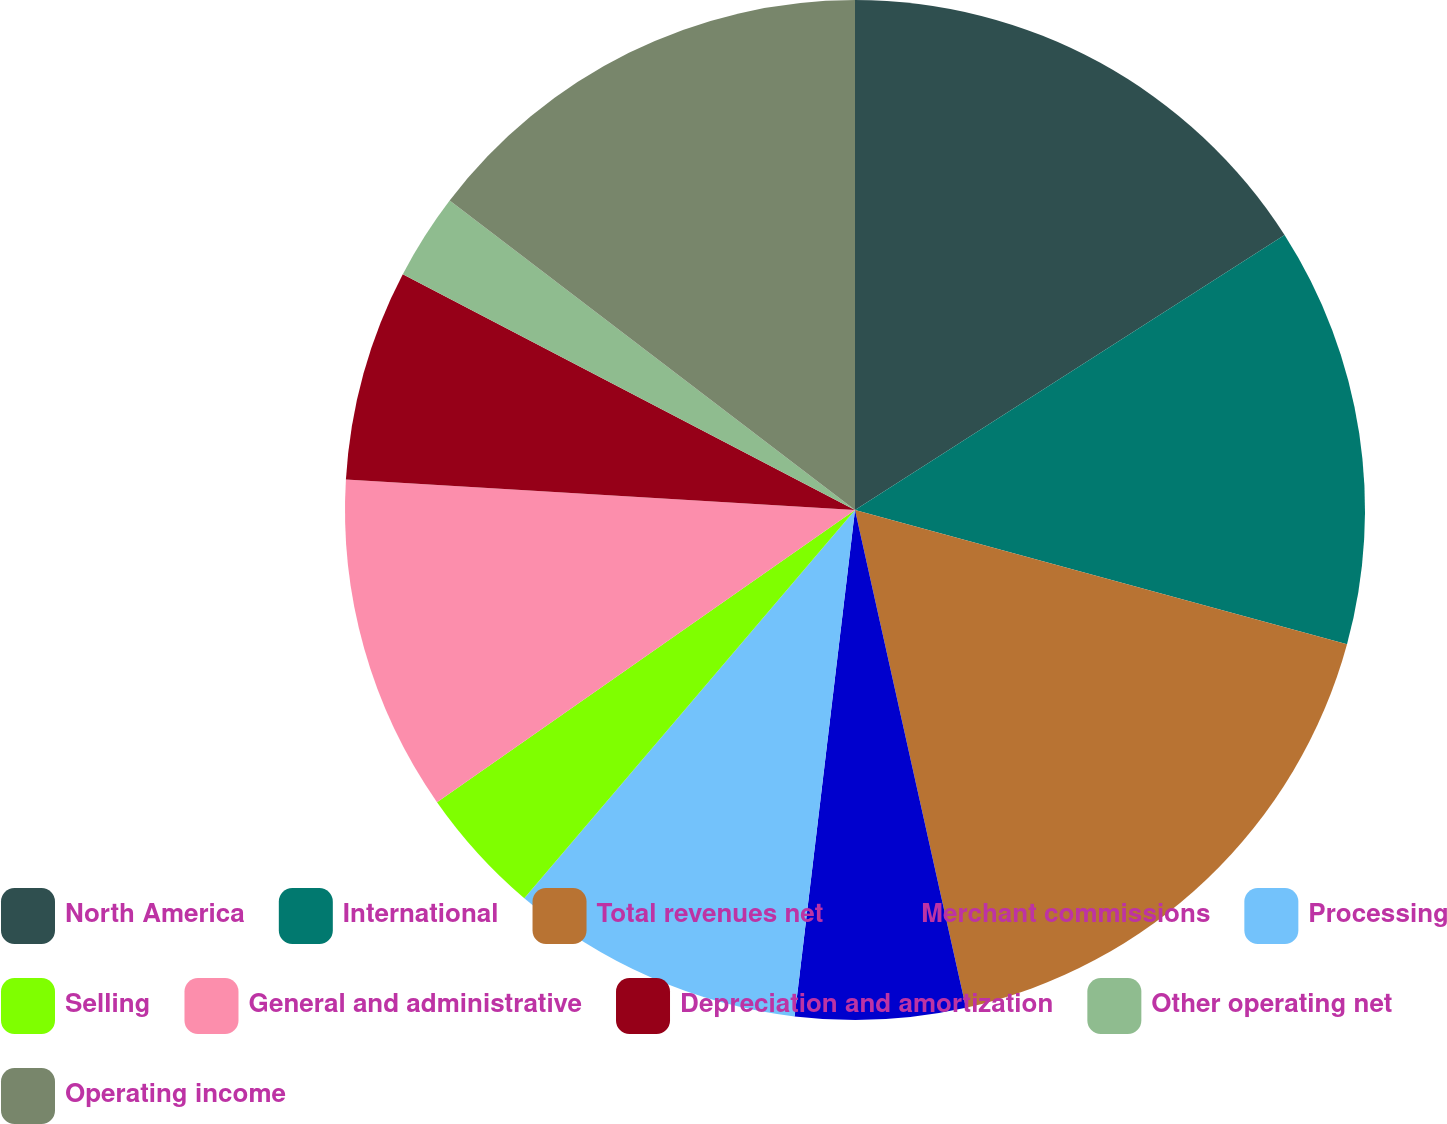<chart> <loc_0><loc_0><loc_500><loc_500><pie_chart><fcel>North America<fcel>International<fcel>Total revenues net<fcel>Merchant commissions<fcel>Processing<fcel>Selling<fcel>General and administrative<fcel>Depreciation and amortization<fcel>Other operating net<fcel>Operating income<nl><fcel>15.94%<fcel>13.3%<fcel>17.27%<fcel>5.38%<fcel>9.34%<fcel>4.06%<fcel>10.66%<fcel>6.7%<fcel>2.73%<fcel>14.62%<nl></chart> 